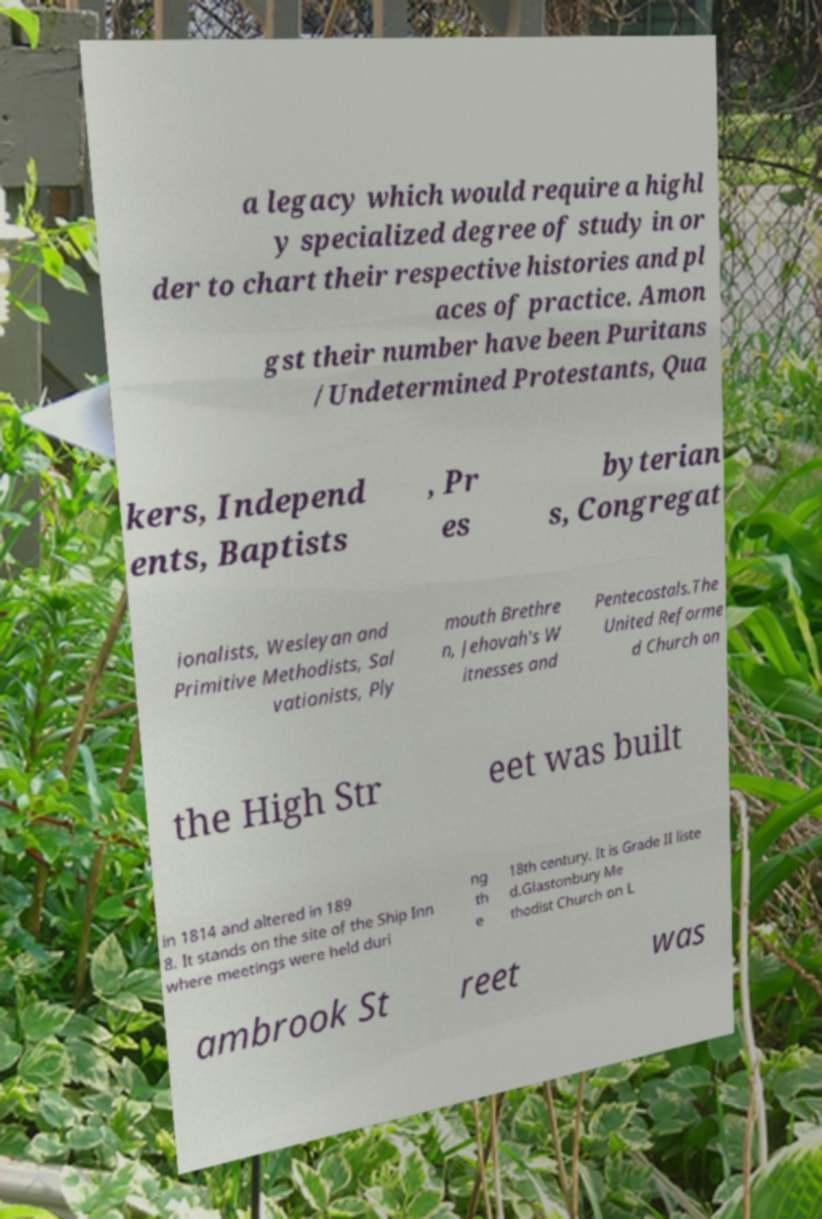Could you extract and type out the text from this image? a legacy which would require a highl y specialized degree of study in or der to chart their respective histories and pl aces of practice. Amon gst their number have been Puritans /Undetermined Protestants, Qua kers, Independ ents, Baptists , Pr es byterian s, Congregat ionalists, Wesleyan and Primitive Methodists, Sal vationists, Ply mouth Brethre n, Jehovah's W itnesses and Pentecostals.The United Reforme d Church on the High Str eet was built in 1814 and altered in 189 8. It stands on the site of the Ship Inn where meetings were held duri ng th e 18th century. It is Grade II liste d.Glastonbury Me thodist Church on L ambrook St reet was 